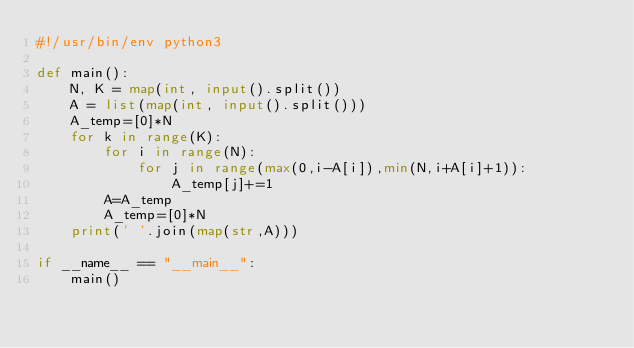Convert code to text. <code><loc_0><loc_0><loc_500><loc_500><_Python_>#!/usr/bin/env python3

def main():
    N, K = map(int, input().split())
    A = list(map(int, input().split()))
    A_temp=[0]*N
    for k in range(K):
        for i in range(N):
            for j in range(max(0,i-A[i]),min(N,i+A[i]+1)):
                A_temp[j]+=1
        A=A_temp
        A_temp=[0]*N
    print(' '.join(map(str,A)))
    
if __name__ == "__main__":
    main()
</code> 